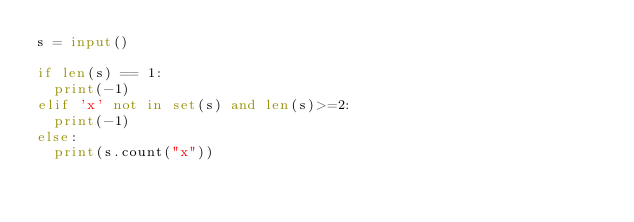<code> <loc_0><loc_0><loc_500><loc_500><_Python_>s = input()

if len(s) == 1:
  print(-1)
elif 'x' not in set(s) and len(s)>=2:
  print(-1)
else:
  print(s.count("x"))
  </code> 